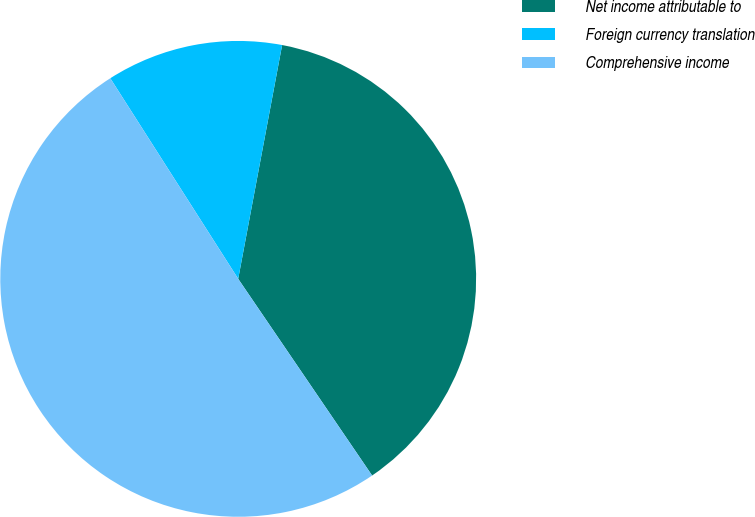Convert chart to OTSL. <chart><loc_0><loc_0><loc_500><loc_500><pie_chart><fcel>Net income attributable to<fcel>Foreign currency translation<fcel>Comprehensive income<nl><fcel>37.53%<fcel>11.99%<fcel>50.48%<nl></chart> 